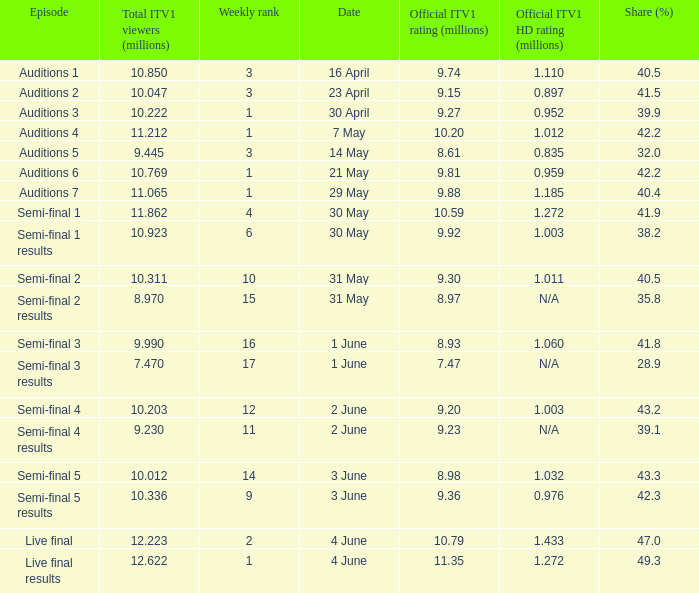When was the episode that had a share (%) of 41.5? 23 April. Could you parse the entire table as a dict? {'header': ['Episode', 'Total ITV1 viewers (millions)', 'Weekly rank', 'Date', 'Official ITV1 rating (millions)', 'Official ITV1 HD rating (millions)', 'Share (%)'], 'rows': [['Auditions 1', '10.850', '3', '16 April', '9.74', '1.110', '40.5'], ['Auditions 2', '10.047', '3', '23 April', '9.15', '0.897', '41.5'], ['Auditions 3', '10.222', '1', '30 April', '9.27', '0.952', '39.9'], ['Auditions 4', '11.212', '1', '7 May', '10.20', '1.012', '42.2'], ['Auditions 5', '9.445', '3', '14 May', '8.61', '0.835', '32.0'], ['Auditions 6', '10.769', '1', '21 May', '9.81', '0.959', '42.2'], ['Auditions 7', '11.065', '1', '29 May', '9.88', '1.185', '40.4'], ['Semi-final 1', '11.862', '4', '30 May', '10.59', '1.272', '41.9'], ['Semi-final 1 results', '10.923', '6', '30 May', '9.92', '1.003', '38.2'], ['Semi-final 2', '10.311', '10', '31 May', '9.30', '1.011', '40.5'], ['Semi-final 2 results', '8.970', '15', '31 May', '8.97', 'N/A', '35.8'], ['Semi-final 3', '9.990', '16', '1 June', '8.93', '1.060', '41.8'], ['Semi-final 3 results', '7.470', '17', '1 June', '7.47', 'N/A', '28.9'], ['Semi-final 4', '10.203', '12', '2 June', '9.20', '1.003', '43.2'], ['Semi-final 4 results', '9.230', '11', '2 June', '9.23', 'N/A', '39.1'], ['Semi-final 5', '10.012', '14', '3 June', '8.98', '1.032', '43.3'], ['Semi-final 5 results', '10.336', '9', '3 June', '9.36', '0.976', '42.3'], ['Live final', '12.223', '2', '4 June', '10.79', '1.433', '47.0'], ['Live final results', '12.622', '1', '4 June', '11.35', '1.272', '49.3']]} 